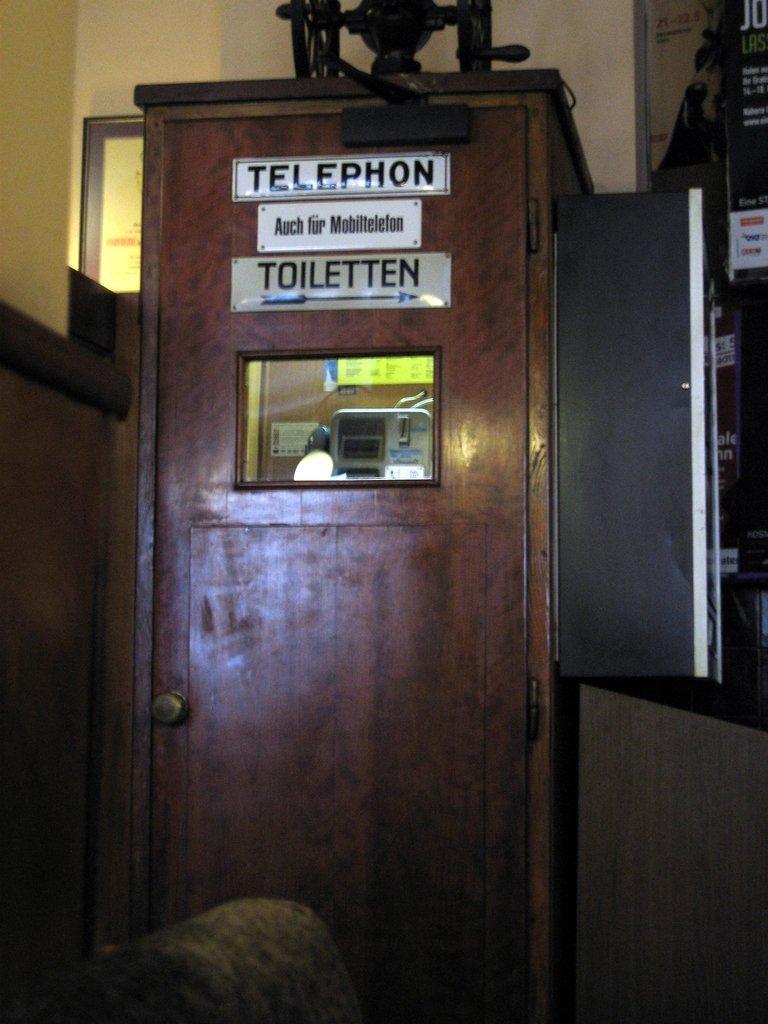Please provide a concise description of this image. In this picture we can see a telephone booth with name boards on it, frame, posters and some objects and in the background we can see the walls. 